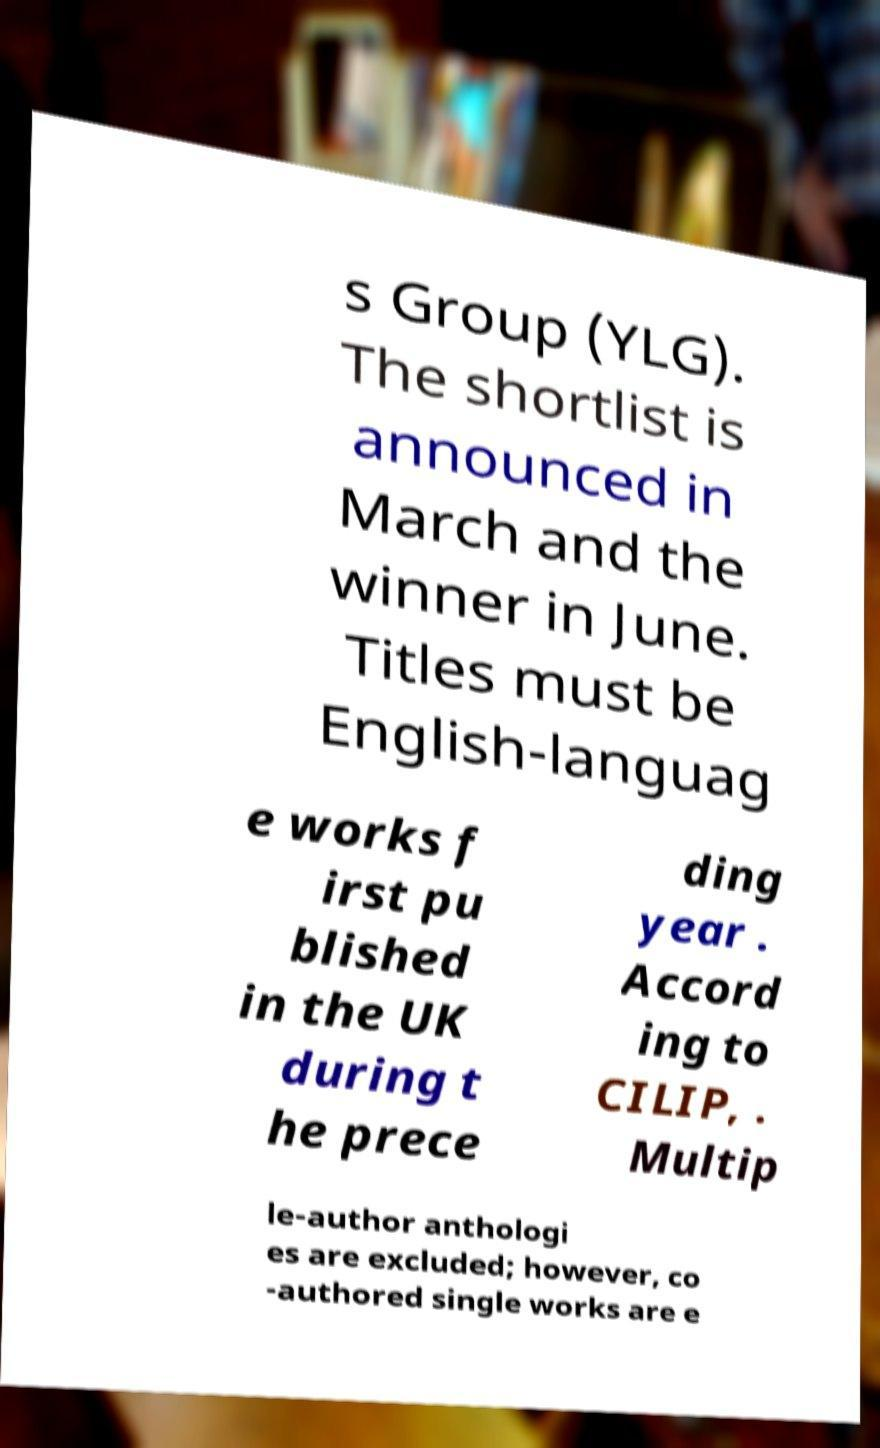Can you read and provide the text displayed in the image?This photo seems to have some interesting text. Can you extract and type it out for me? s Group (YLG). The shortlist is announced in March and the winner in June. Titles must be English-languag e works f irst pu blished in the UK during t he prece ding year . Accord ing to CILIP, . Multip le-author anthologi es are excluded; however, co -authored single works are e 